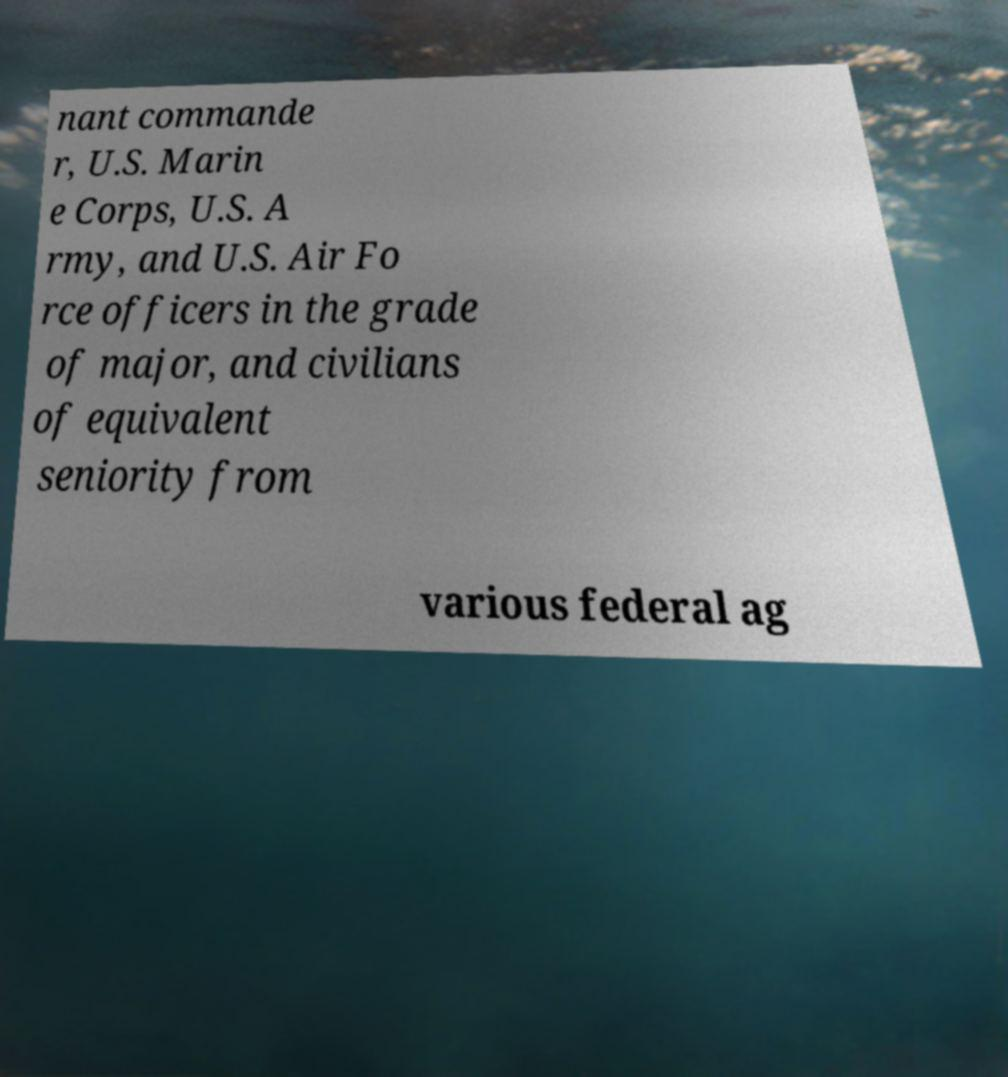There's text embedded in this image that I need extracted. Can you transcribe it verbatim? nant commande r, U.S. Marin e Corps, U.S. A rmy, and U.S. Air Fo rce officers in the grade of major, and civilians of equivalent seniority from various federal ag 